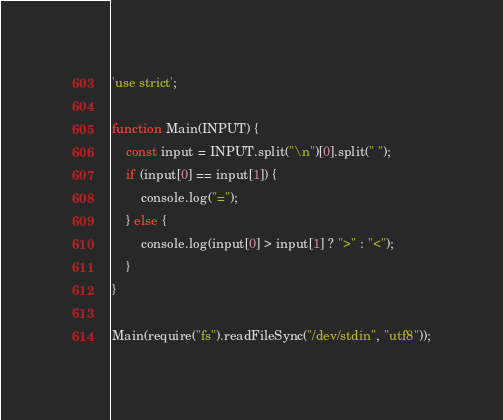Convert code to text. <code><loc_0><loc_0><loc_500><loc_500><_JavaScript_>'use strict';

function Main(INPUT) {
    const input = INPUT.split("\n")[0].split(" ");
    if (input[0] == input[1]) {
        console.log("=");
    } else {
        console.log(input[0] > input[1] ? ">" : "<");
    }
}

Main(require("fs").readFileSync("/dev/stdin", "utf8"));
</code> 